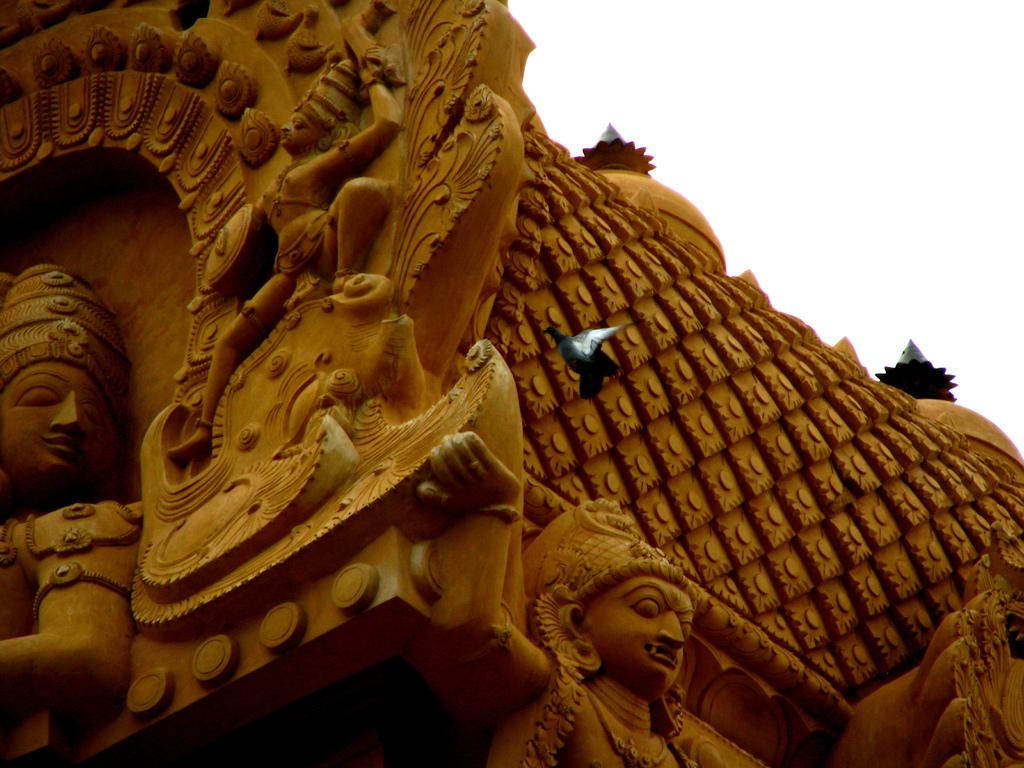What is the main subject of the image? There is a bird flying in the image. What type of structure can be seen in the image? There is a building in the image. Are there any decorative elements on the building? Yes, there are sculptures on the building. What is visible towards the top of the image? The sky is visible towards the top of the image. What type of vessel is being used by the beggar in the image? There is no beggar or vessel present in the image. What type of crack can be seen on the bird's wing in the image? There is no crack visible on the bird's wing in the image; the bird appears to be flying without any visible damage. 